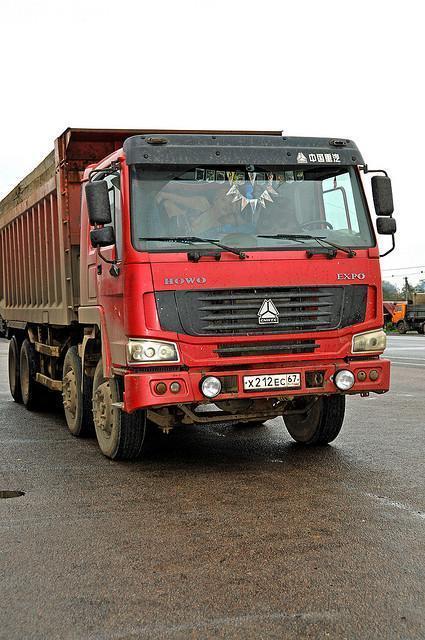How many tires are on the truck?
Give a very brief answer. 8. 